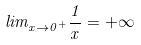<formula> <loc_0><loc_0><loc_500><loc_500>l i m _ { x \rightarrow 0 ^ { + } } \frac { 1 } { x } = + \infty</formula> 